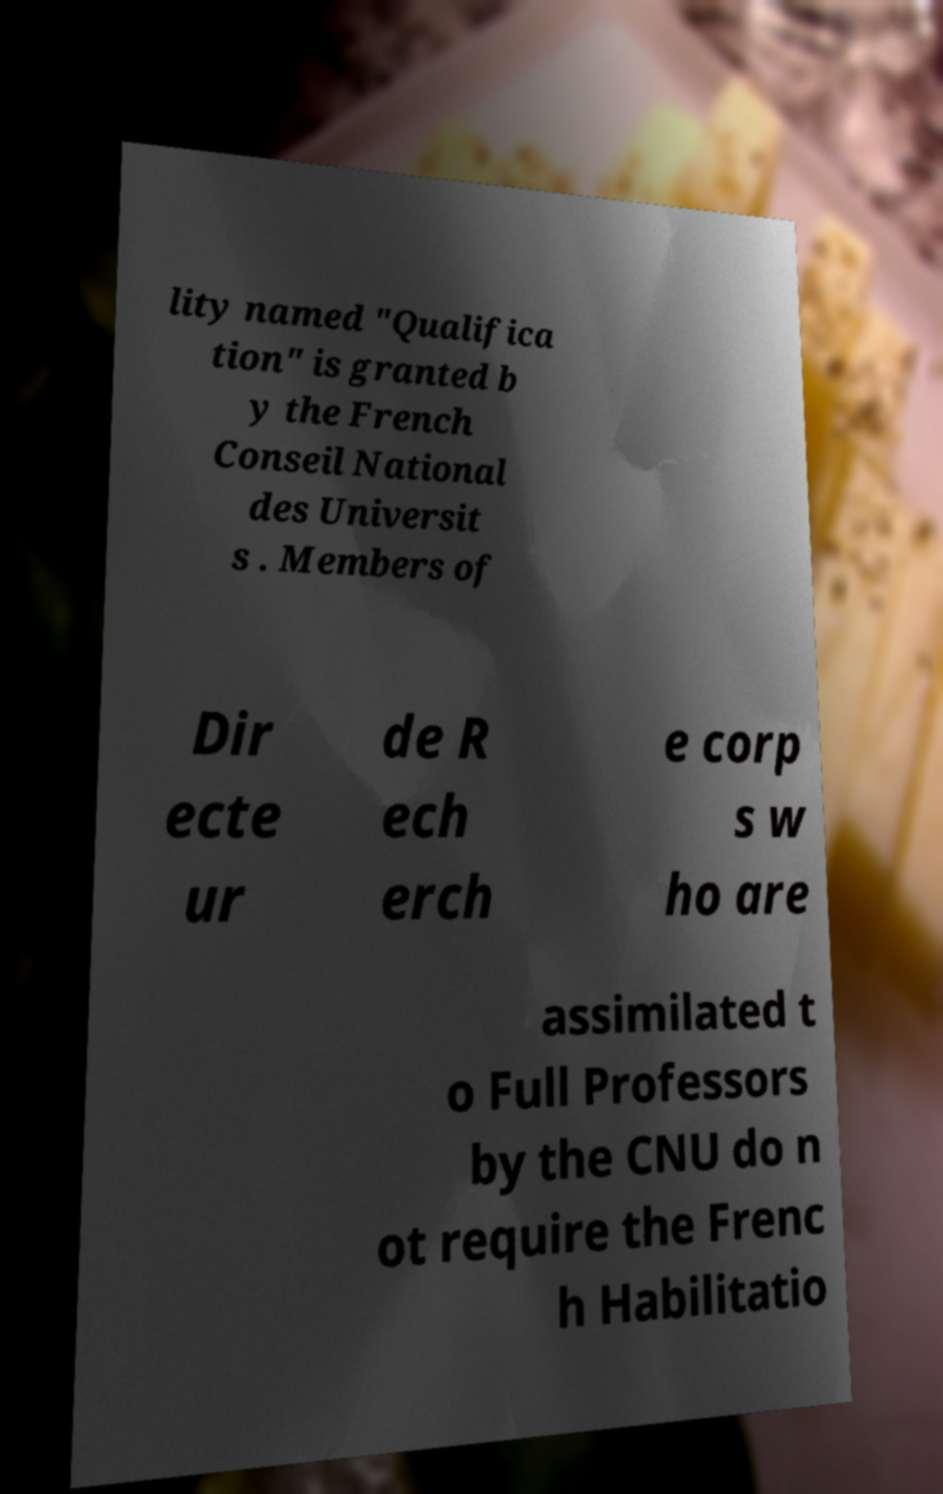There's text embedded in this image that I need extracted. Can you transcribe it verbatim? lity named "Qualifica tion" is granted b y the French Conseil National des Universit s . Members of Dir ecte ur de R ech erch e corp s w ho are assimilated t o Full Professors by the CNU do n ot require the Frenc h Habilitatio 